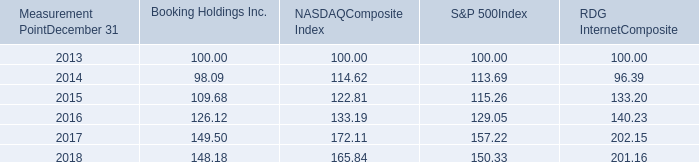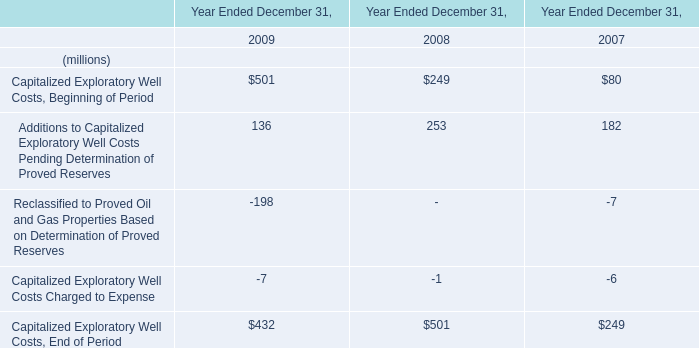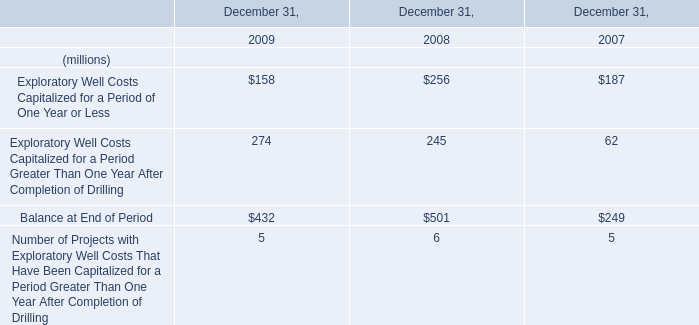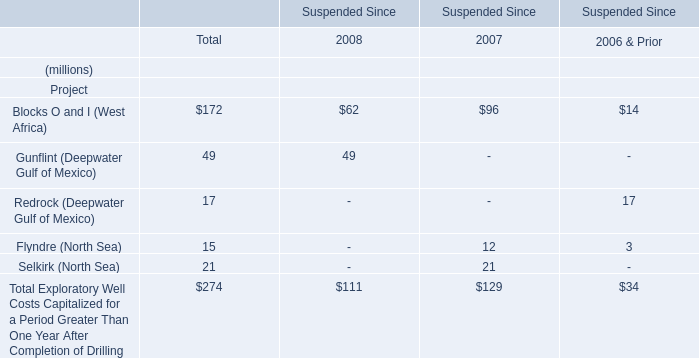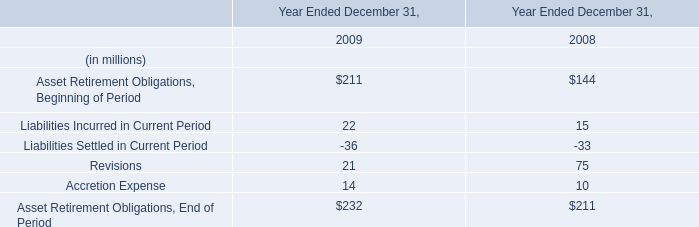What is the sum of Capitalized Exploratory Well Costs Charged to Expense in 2009? (in million) 
Answer: -7.0. 